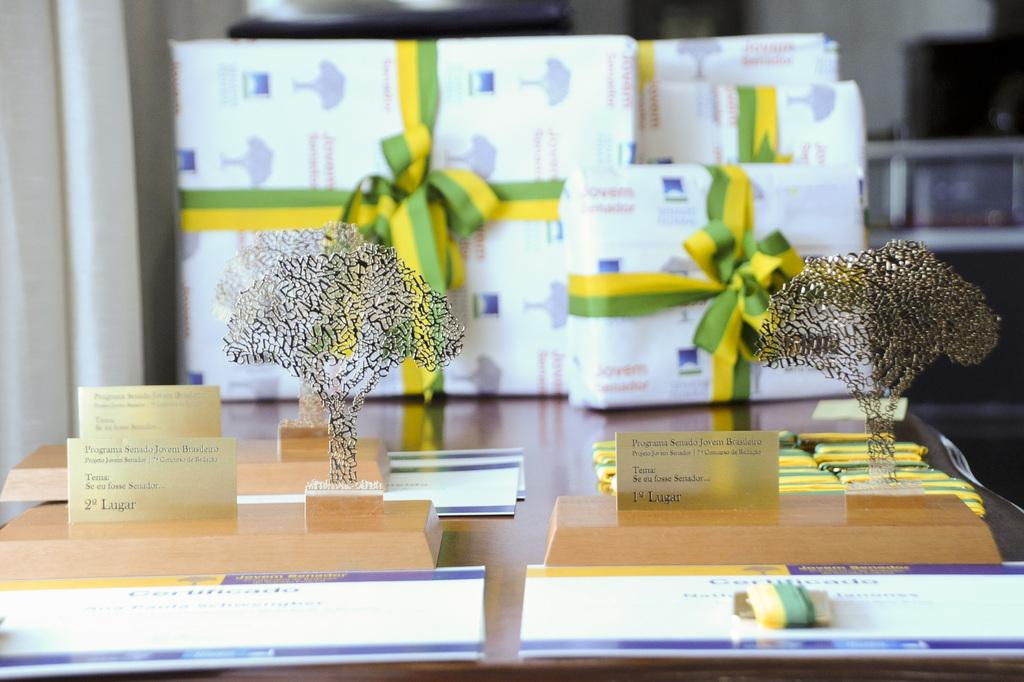What objects are on the wooden stand in the image? There are small glass trees on a wooden stand in the image. What is placed in front of the glass trees? There are cards in front of the glass trees. Where are the glass trees, cards, and wooden stand located? They are on a table in the image. What else can be seen behind the table? There are presents visible behind the table. What type of jar can be seen on the edge of the table in the image? There is no jar visible on the edge of the table in the image. Is there a pig present in the image? No, there is no pig present in the image. 